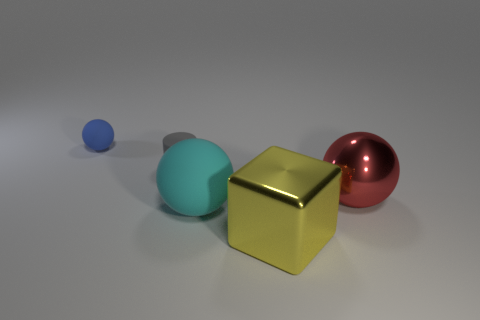Add 5 matte cylinders. How many objects exist? 10 Subtract all spheres. How many objects are left? 2 Add 2 small rubber objects. How many small rubber objects are left? 4 Add 4 big objects. How many big objects exist? 7 Subtract 0 cyan cylinders. How many objects are left? 5 Subtract all big cyan rubber balls. Subtract all large green blocks. How many objects are left? 4 